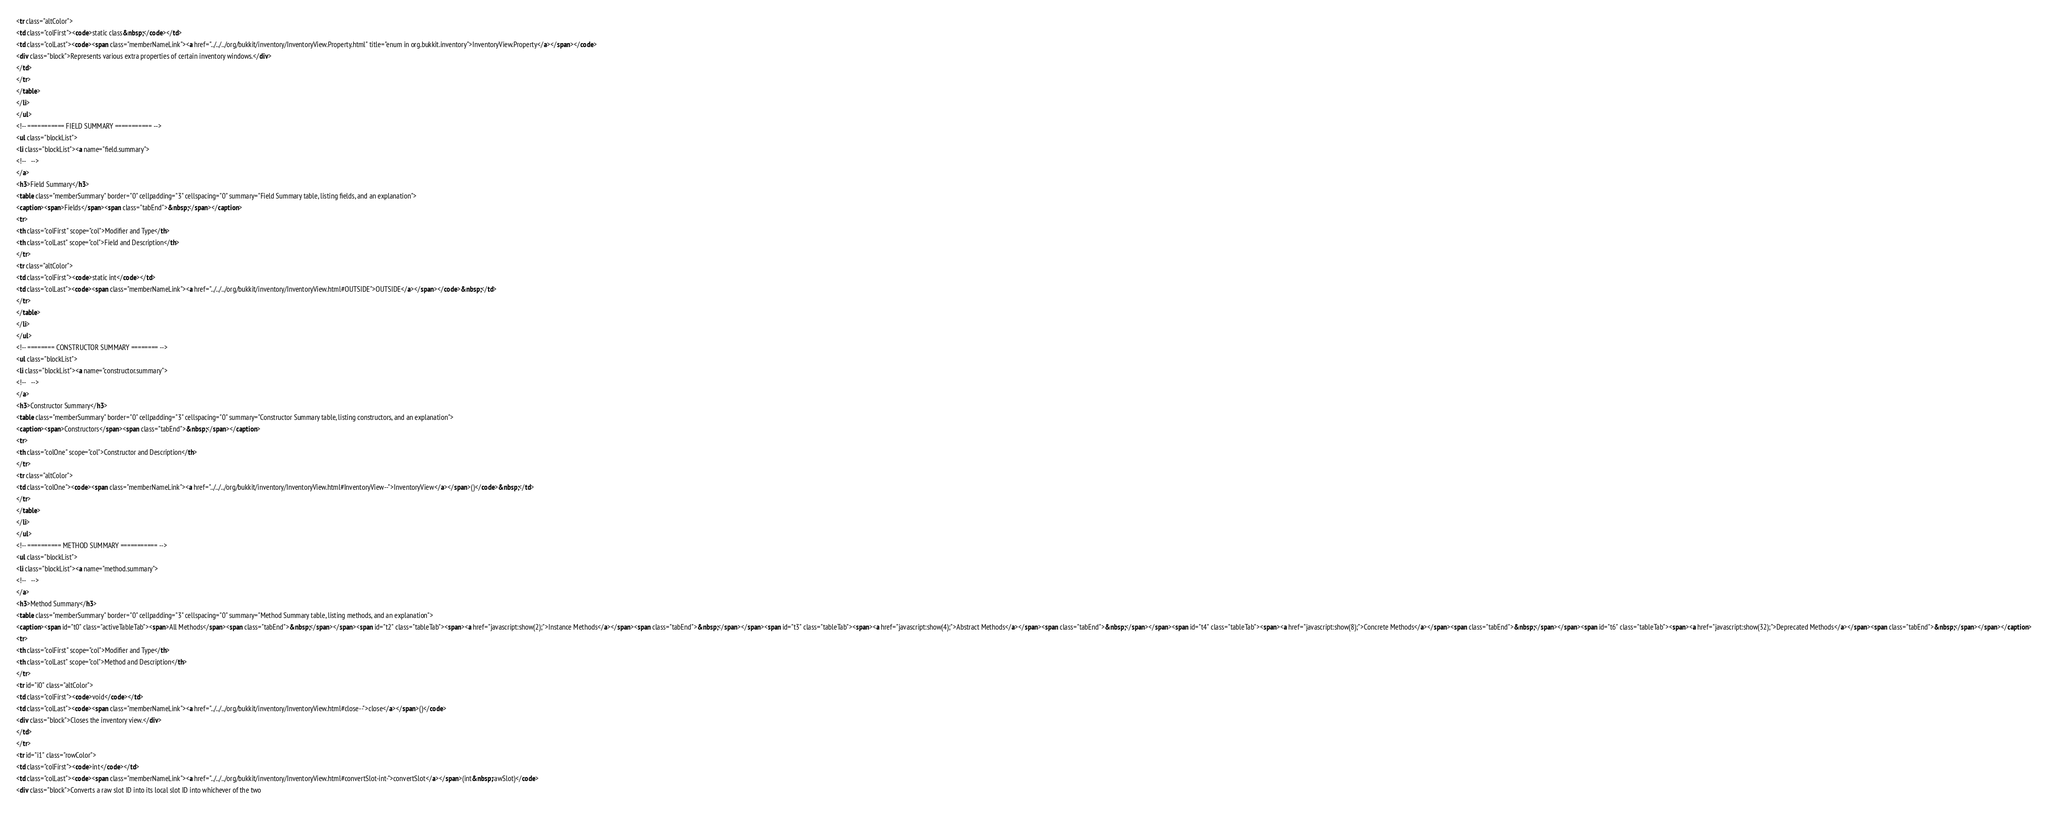<code> <loc_0><loc_0><loc_500><loc_500><_HTML_><tr class="altColor">
<td class="colFirst"><code>static class&nbsp;</code></td>
<td class="colLast"><code><span class="memberNameLink"><a href="../../../org/bukkit/inventory/InventoryView.Property.html" title="enum in org.bukkit.inventory">InventoryView.Property</a></span></code>
<div class="block">Represents various extra properties of certain inventory windows.</div>
</td>
</tr>
</table>
</li>
</ul>
<!-- =========== FIELD SUMMARY =========== -->
<ul class="blockList">
<li class="blockList"><a name="field.summary">
<!--   -->
</a>
<h3>Field Summary</h3>
<table class="memberSummary" border="0" cellpadding="3" cellspacing="0" summary="Field Summary table, listing fields, and an explanation">
<caption><span>Fields</span><span class="tabEnd">&nbsp;</span></caption>
<tr>
<th class="colFirst" scope="col">Modifier and Type</th>
<th class="colLast" scope="col">Field and Description</th>
</tr>
<tr class="altColor">
<td class="colFirst"><code>static int</code></td>
<td class="colLast"><code><span class="memberNameLink"><a href="../../../org/bukkit/inventory/InventoryView.html#OUTSIDE">OUTSIDE</a></span></code>&nbsp;</td>
</tr>
</table>
</li>
</ul>
<!-- ======== CONSTRUCTOR SUMMARY ======== -->
<ul class="blockList">
<li class="blockList"><a name="constructor.summary">
<!--   -->
</a>
<h3>Constructor Summary</h3>
<table class="memberSummary" border="0" cellpadding="3" cellspacing="0" summary="Constructor Summary table, listing constructors, and an explanation">
<caption><span>Constructors</span><span class="tabEnd">&nbsp;</span></caption>
<tr>
<th class="colOne" scope="col">Constructor and Description</th>
</tr>
<tr class="altColor">
<td class="colOne"><code><span class="memberNameLink"><a href="../../../org/bukkit/inventory/InventoryView.html#InventoryView--">InventoryView</a></span>()</code>&nbsp;</td>
</tr>
</table>
</li>
</ul>
<!-- ========== METHOD SUMMARY =========== -->
<ul class="blockList">
<li class="blockList"><a name="method.summary">
<!--   -->
</a>
<h3>Method Summary</h3>
<table class="memberSummary" border="0" cellpadding="3" cellspacing="0" summary="Method Summary table, listing methods, and an explanation">
<caption><span id="t0" class="activeTableTab"><span>All Methods</span><span class="tabEnd">&nbsp;</span></span><span id="t2" class="tableTab"><span><a href="javascript:show(2);">Instance Methods</a></span><span class="tabEnd">&nbsp;</span></span><span id="t3" class="tableTab"><span><a href="javascript:show(4);">Abstract Methods</a></span><span class="tabEnd">&nbsp;</span></span><span id="t4" class="tableTab"><span><a href="javascript:show(8);">Concrete Methods</a></span><span class="tabEnd">&nbsp;</span></span><span id="t6" class="tableTab"><span><a href="javascript:show(32);">Deprecated Methods</a></span><span class="tabEnd">&nbsp;</span></span></caption>
<tr>
<th class="colFirst" scope="col">Modifier and Type</th>
<th class="colLast" scope="col">Method and Description</th>
</tr>
<tr id="i0" class="altColor">
<td class="colFirst"><code>void</code></td>
<td class="colLast"><code><span class="memberNameLink"><a href="../../../org/bukkit/inventory/InventoryView.html#close--">close</a></span>()</code>
<div class="block">Closes the inventory view.</div>
</td>
</tr>
<tr id="i1" class="rowColor">
<td class="colFirst"><code>int</code></td>
<td class="colLast"><code><span class="memberNameLink"><a href="../../../org/bukkit/inventory/InventoryView.html#convertSlot-int-">convertSlot</a></span>(int&nbsp;rawSlot)</code>
<div class="block">Converts a raw slot ID into its local slot ID into whichever of the two</code> 